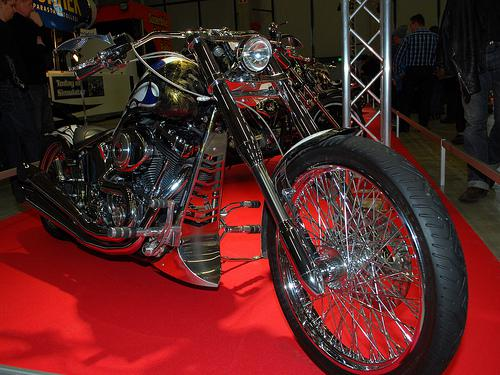Question: where are the people?
Choices:
A. At the dance.
B. At school.
C. At a reunion.
D. A motorcycle show.
Answer with the letter. Answer: D Question: why is the motorcycle on the stand?
Choices:
A. For display.
B. It's broke.
C. He wrecked it.
D. In garage.
Answer with the letter. Answer: A Question: what is the motorcycle on?
Choices:
A. The driveway.
B. A display stand.
C. The beach.
D. The road.
Answer with the letter. Answer: B 